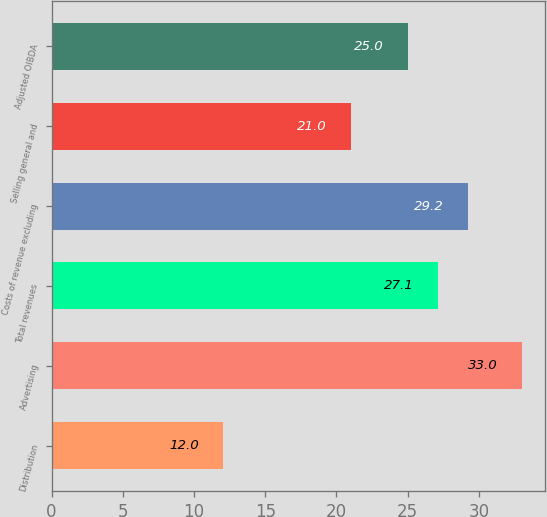Convert chart. <chart><loc_0><loc_0><loc_500><loc_500><bar_chart><fcel>Distribution<fcel>Advertising<fcel>Total revenues<fcel>Costs of revenue excluding<fcel>Selling general and<fcel>Adjusted OIBDA<nl><fcel>12<fcel>33<fcel>27.1<fcel>29.2<fcel>21<fcel>25<nl></chart> 